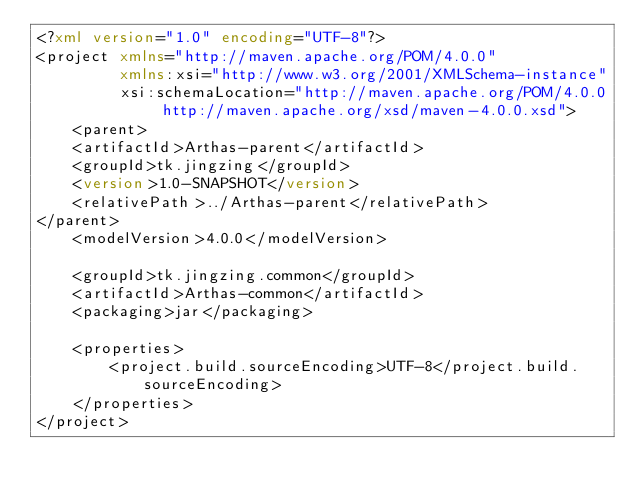<code> <loc_0><loc_0><loc_500><loc_500><_XML_><?xml version="1.0" encoding="UTF-8"?>
<project xmlns="http://maven.apache.org/POM/4.0.0"
         xmlns:xsi="http://www.w3.org/2001/XMLSchema-instance"
         xsi:schemaLocation="http://maven.apache.org/POM/4.0.0 http://maven.apache.org/xsd/maven-4.0.0.xsd">
    <parent>
    <artifactId>Arthas-parent</artifactId>
    <groupId>tk.jingzing</groupId>
    <version>1.0-SNAPSHOT</version>
    <relativePath>../Arthas-parent</relativePath>
</parent>
    <modelVersion>4.0.0</modelVersion>

    <groupId>tk.jingzing.common</groupId>
    <artifactId>Arthas-common</artifactId>
    <packaging>jar</packaging>

    <properties>
        <project.build.sourceEncoding>UTF-8</project.build.sourceEncoding>
    </properties>
</project></code> 